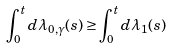Convert formula to latex. <formula><loc_0><loc_0><loc_500><loc_500>\int _ { 0 } ^ { t } d \lambda _ { 0 , \gamma } ( s ) \geq \int _ { 0 } ^ { t } d \lambda _ { 1 } ( s )</formula> 